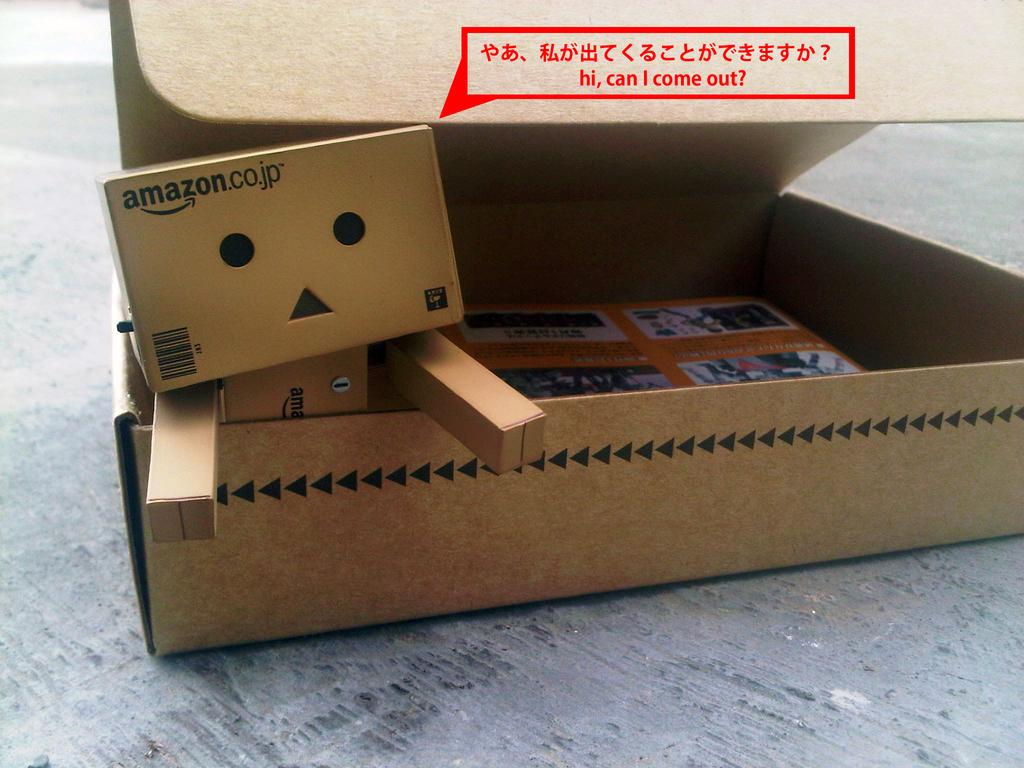<image>
Present a compact description of the photo's key features. The cute cardboard robot is made with amazon boxes. 